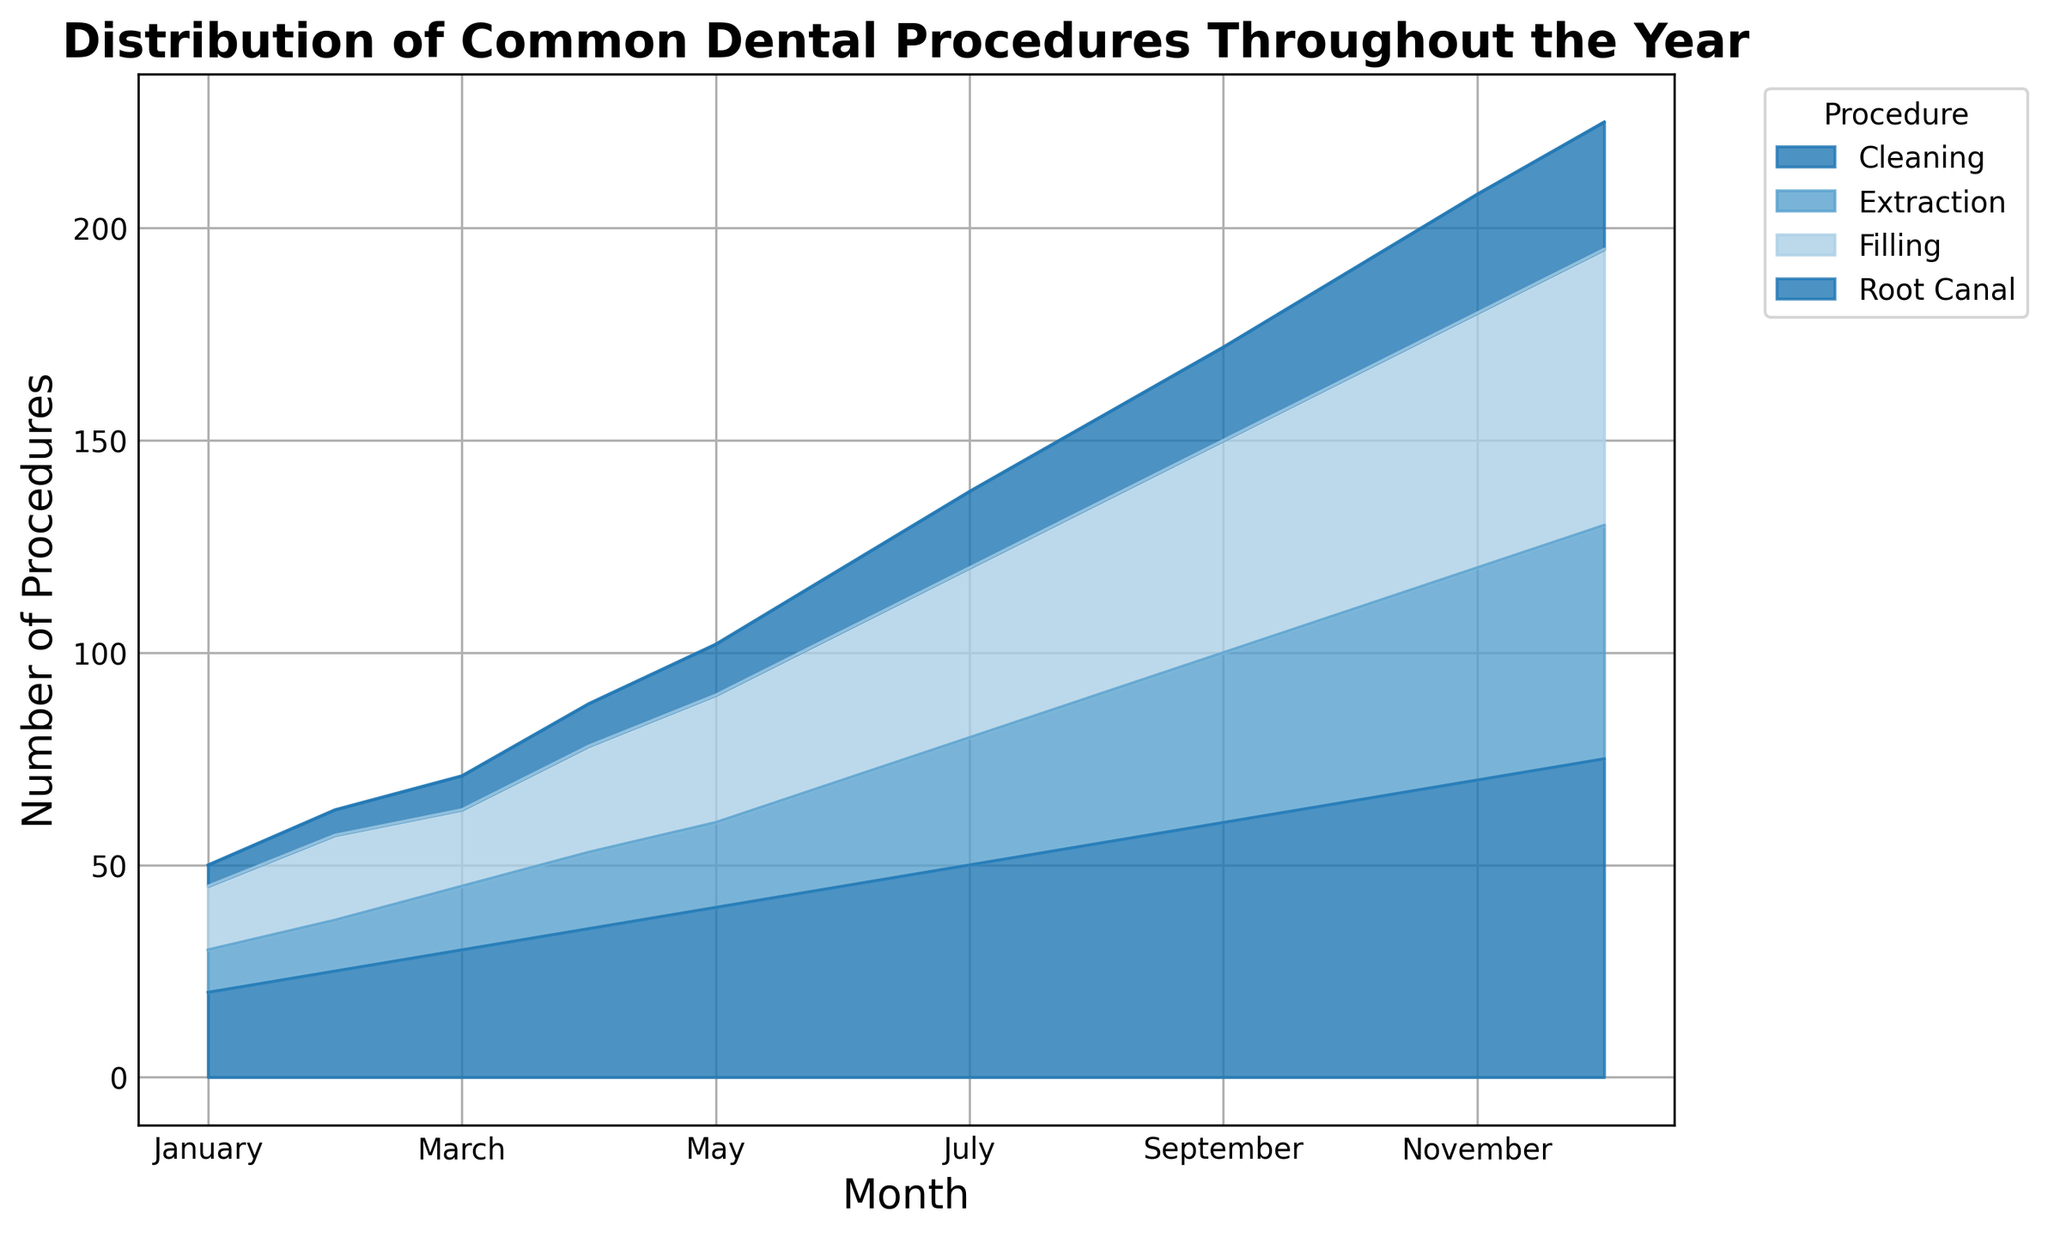What is the procedure with the highest count in December? Look at the December column and identify the procedure with the highest stacked height. Cleaning has the highest count.
Answer: Cleaning How many total procedures were performed in June? Add up all the counts for each procedure in the June column: 45 (Cleaning) + 35 (Filling) + 25 (Extraction) + 15 (Root Canal) = 120
Answer: 120 Which month had the highest number of Root Canal procedures? Identify the month where the color representing Root Canal reaches the tallest height. December has the highest count for Root Canal at 30.
Answer: December By how much did the number of Cleaning procedures increase from January to July? Subtract the number of Cleaning procedures in January from the number in July: 50 (July) - 20 (January) = 30
Answer: 30 Which procedure shows the least variation in counts over the year? Observe the areas plotted for each procedure and identify the one with the least fluctuation in height. Extraction has relatively consistent heights compared to others.
Answer: Extraction What is the average number of Extraction procedures performed from May to August? Add up the Extraction counts for May, June, July, and August and divide by 4: (20 + 25 + 30 + 35) / 4 = 110 / 4 = 27.5
Answer: 27.5 In which month was the total number of dental procedures the highest? Identify the month where the total stacked height reaches its maximum. December shows the tallest combined height.
Answer: December Compare the total number of Filling procedures in the first half of the year to the second half. Add the Filling counts for January to June and July to December: First half = 15 + 20 + 18 + 25 + 30 + 35 = 143, Second half = 40 + 45 + 50 + 55 + 60 + 65 = 315
Answer: Second half What is the difference in total procedures between April and September? Calculate the total for April and September, then find their difference: April = 35 (Cleaning) + 25 (Filling) + 18 (Extraction) + 10 (Root Canal) = 88; September = 60 (Cleaning) + 50 (Filling) + 40 (Extraction) + 22 (Root Canal) = 172; Difference = 172 - 88 = 84
Answer: 84 